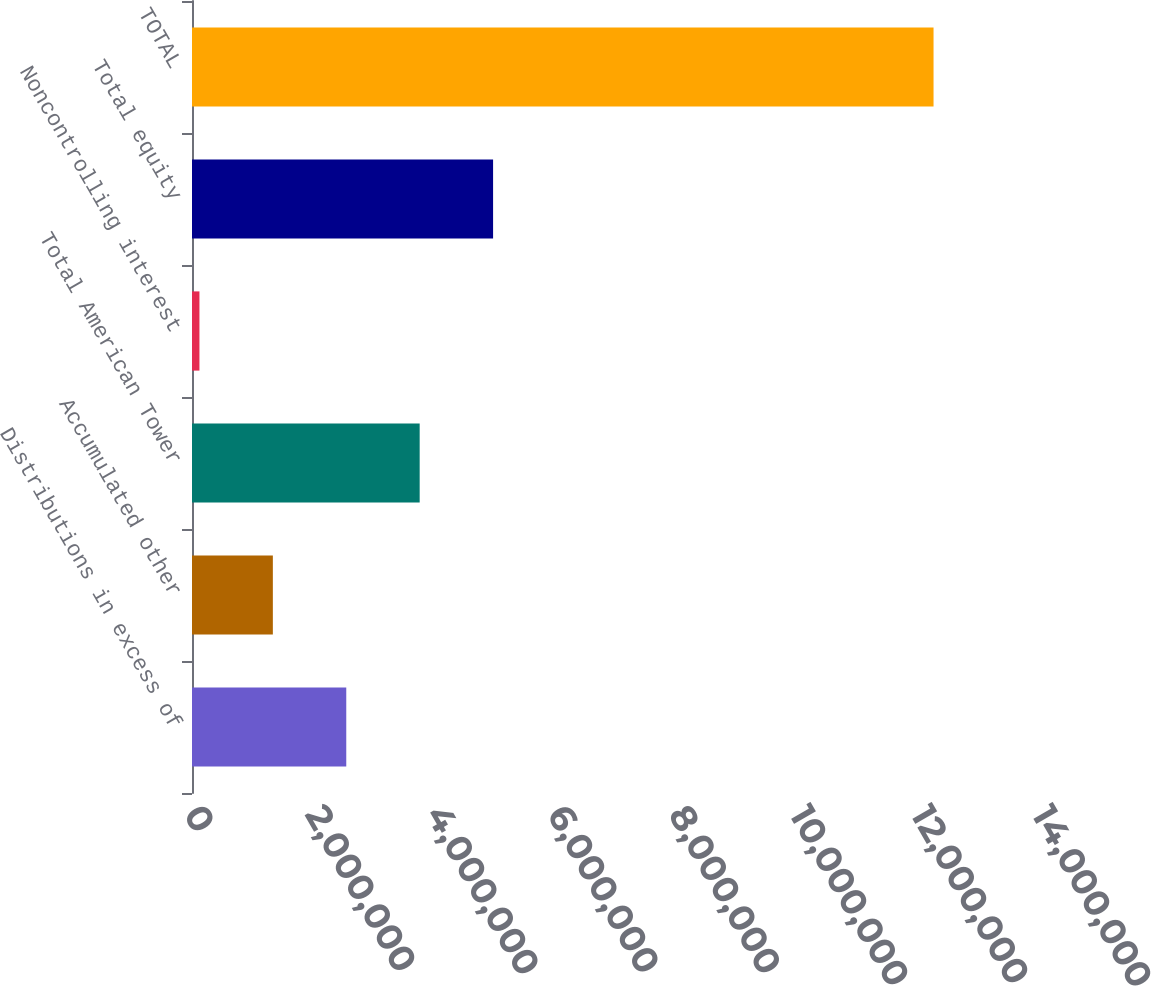Convert chart to OTSL. <chart><loc_0><loc_0><loc_500><loc_500><bar_chart><fcel>Distributions in excess of<fcel>Accumulated other<fcel>Total American Tower<fcel>Noncontrolling interest<fcel>Total equity<fcel>TOTAL<nl><fcel>2.54682e+06<fcel>1.33487e+06<fcel>3.75876e+06<fcel>122922<fcel>4.97071e+06<fcel>1.22424e+07<nl></chart> 